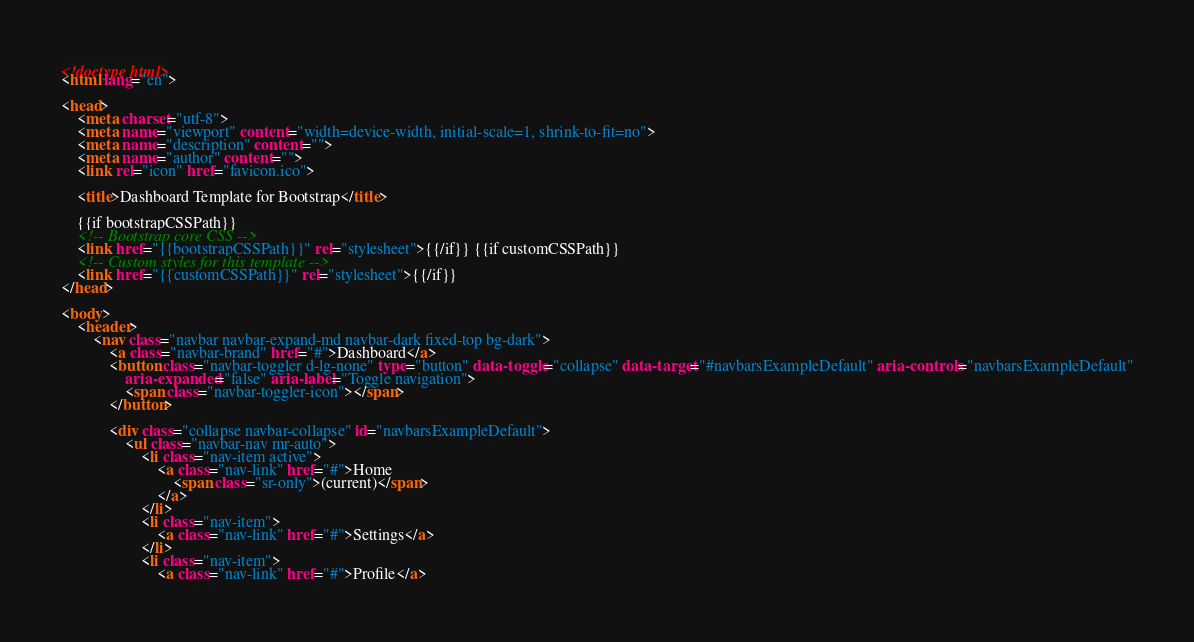<code> <loc_0><loc_0><loc_500><loc_500><_HTML_><!doctype html>
<html lang="en">

<head>
	<meta charset="utf-8">
	<meta name="viewport" content="width=device-width, initial-scale=1, shrink-to-fit=no">
	<meta name="description" content="">
	<meta name="author" content="">
	<link rel="icon" href="favicon.ico">

	<title>Dashboard Template for Bootstrap</title>

	{{if bootstrapCSSPath}}
	<!-- Bootstrap core CSS -->
	<link href="{{bootstrapCSSPath}}" rel="stylesheet">{{/if}} {{if customCSSPath}}
	<!-- Custom styles for this template -->
	<link href="{{customCSSPath}}" rel="stylesheet">{{/if}}
</head>

<body>
	<header>
		<nav class="navbar navbar-expand-md navbar-dark fixed-top bg-dark">
			<a class="navbar-brand" href="#">Dashboard</a>
			<button class="navbar-toggler d-lg-none" type="button" data-toggle="collapse" data-target="#navbarsExampleDefault" aria-controls="navbarsExampleDefault"
				aria-expanded="false" aria-label="Toggle navigation">
				<span class="navbar-toggler-icon"></span>
			</button>

			<div class="collapse navbar-collapse" id="navbarsExampleDefault">
				<ul class="navbar-nav mr-auto">
					<li class="nav-item active">
						<a class="nav-link" href="#">Home
							<span class="sr-only">(current)</span>
						</a>
					</li>
					<li class="nav-item">
						<a class="nav-link" href="#">Settings</a>
					</li>
					<li class="nav-item">
						<a class="nav-link" href="#">Profile</a></code> 